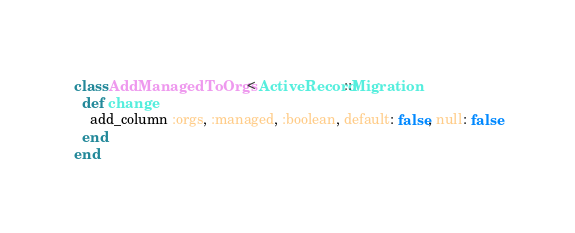<code> <loc_0><loc_0><loc_500><loc_500><_Ruby_>class AddManagedToOrgs < ActiveRecord::Migration
  def change
    add_column :orgs, :managed, :boolean, default: false, null: false
  end
end
</code> 